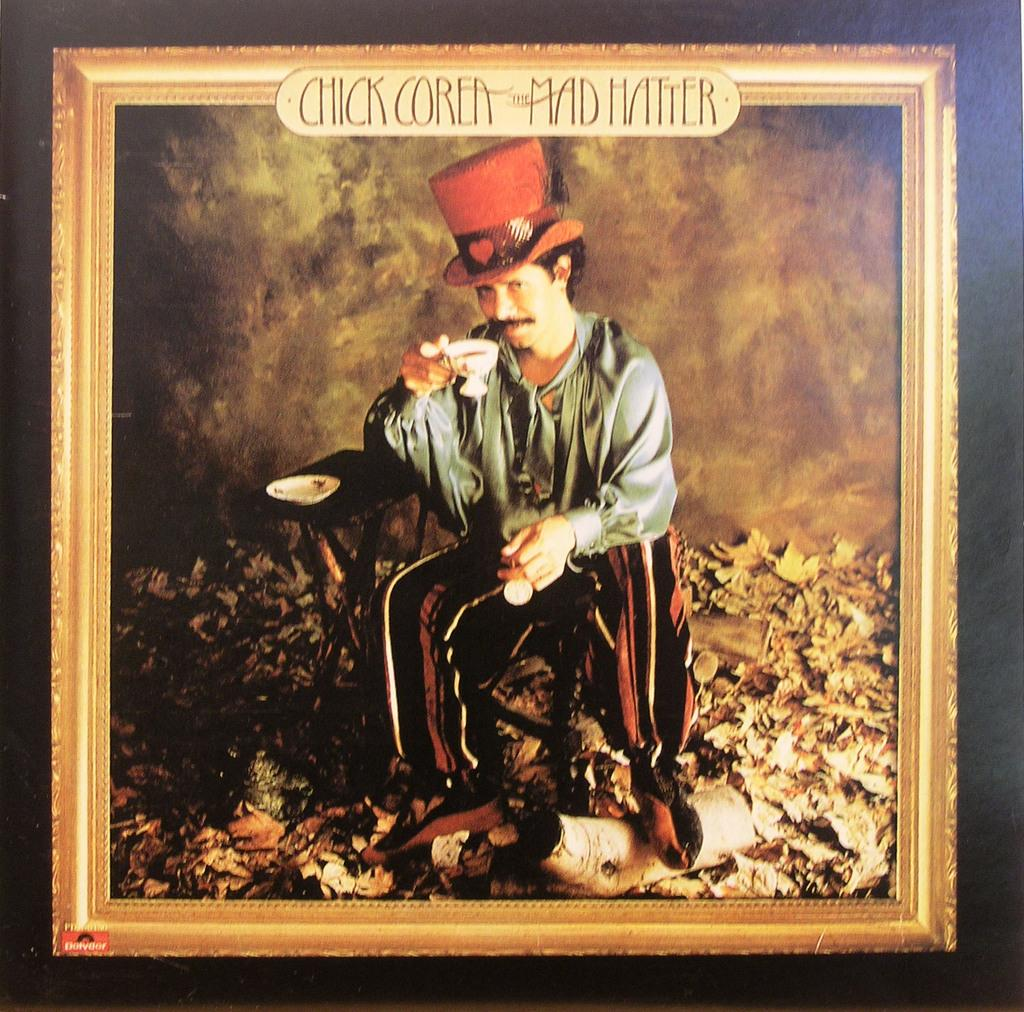<image>
Share a concise interpretation of the image provided. A painting of a man with the label Chick Corea the mad hatter above him. 